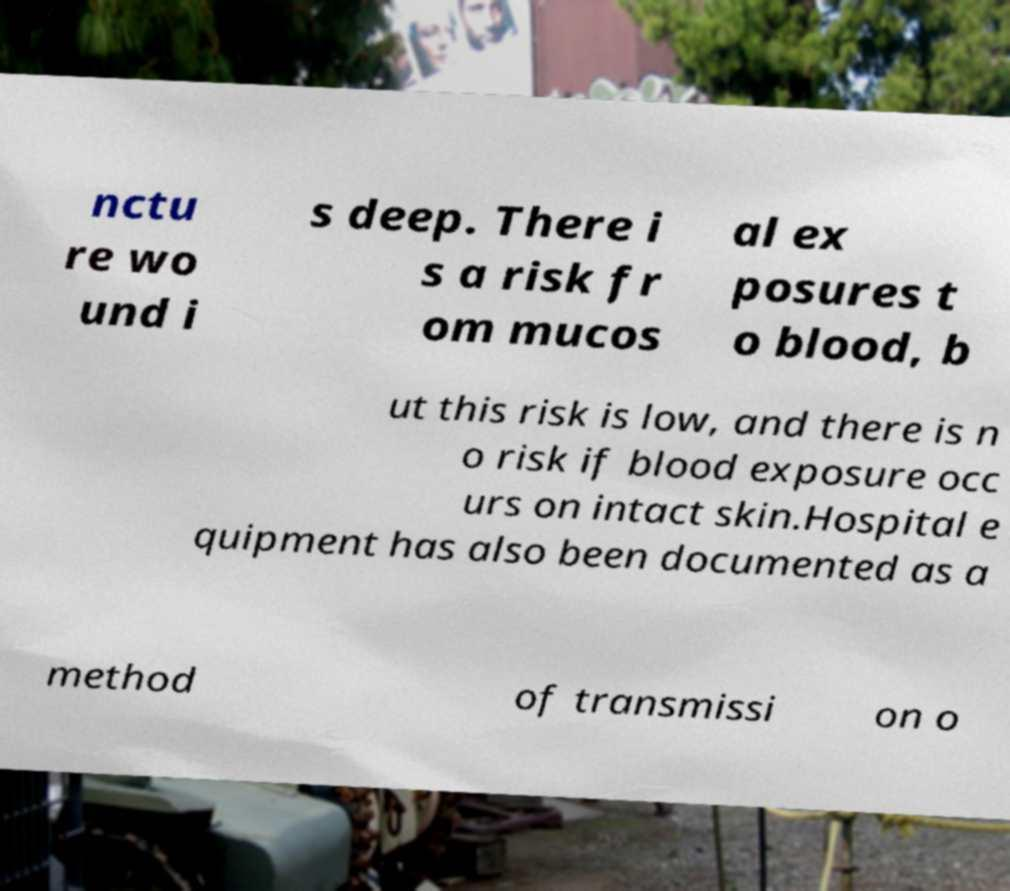I need the written content from this picture converted into text. Can you do that? nctu re wo und i s deep. There i s a risk fr om mucos al ex posures t o blood, b ut this risk is low, and there is n o risk if blood exposure occ urs on intact skin.Hospital e quipment has also been documented as a method of transmissi on o 